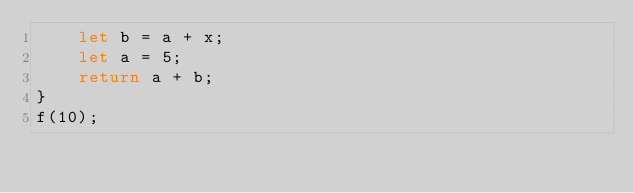<code> <loc_0><loc_0><loc_500><loc_500><_JavaScript_>    let b = a + x;
    let a = 5;
    return a + b;
}
f(10);</code> 